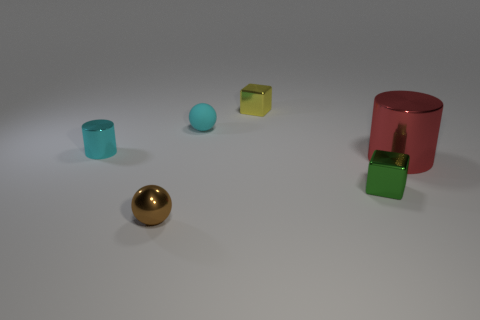Add 2 cyan matte balls. How many objects exist? 8 Subtract all cylinders. How many objects are left? 4 Add 6 tiny red rubber spheres. How many tiny red rubber spheres exist? 6 Subtract 0 blue cubes. How many objects are left? 6 Subtract all small cyan things. Subtract all red things. How many objects are left? 3 Add 2 matte balls. How many matte balls are left? 3 